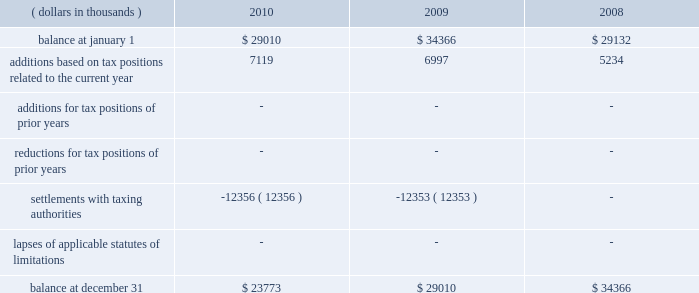A reconciliation of the beginning and ending amount of unrecognized tax benefits , for the periods indicated , is as follows: .
The entire amount of the unrecognized tax benefits would affect the effective tax rate if recognized .
In 2010 , the company favorably settled a 2003 and 2004 irs audit .
The company recorded a net overall tax benefit including accrued interest of $ 25920 thousand .
In addition , the company was also able to take down a $ 12356 thousand fin 48 reserve that had been established regarding the 2003 and 2004 irs audit .
The company is no longer subject to u.s .
Federal , state and local or foreign income tax examinations by tax authorities for years before 2007 .
The company recognizes accrued interest related to net unrecognized tax benefits and penalties in income taxes .
During the years ended december 31 , 2010 , 2009 and 2008 , the company accrued and recognized a net expense ( benefit ) of approximately $ ( 9938 ) thousand , $ 1563 thousand and $ 2446 thousand , respectively , in interest and penalties .
Included within the 2010 net expense ( benefit ) of $ ( 9938 ) thousand is $ ( 10591 ) thousand of accrued interest related to the 2003 and 2004 irs audit .
The company is not aware of any positions for which it is reasonably possible that the total amounts of unrecognized tax benefits will significantly increase or decrease within twelve months of the reporting date .
For u.s .
Income tax purposes the company has foreign tax credit carryforwards of $ 55026 thousand that begin to expire in 2014 .
In addition , for u.s .
Income tax purposes the company has $ 41693 thousand of alternative minimum tax credits that do not expire .
Management believes that it is more likely than not that the company will realize the benefits of its net deferred tax assets and , accordingly , no valuation allowance has been recorded for the periods presented .
Tax benefits of $ 629 thousand and $ 1714 thousand related to share-based compensation deductions for stock options exercised in 2010 and 2009 , respectively , are included within additional paid-in capital of the shareholders 2019 equity section of the consolidated balance sheets. .
What was the percent change in net expense in interest and penalties between 2008 and 2009? 
Computations: ((1563 - 2446) / 2446)
Answer: -0.361. A reconciliation of the beginning and ending amount of unrecognized tax benefits , for the periods indicated , is as follows: .
The entire amount of the unrecognized tax benefits would affect the effective tax rate if recognized .
In 2010 , the company favorably settled a 2003 and 2004 irs audit .
The company recorded a net overall tax benefit including accrued interest of $ 25920 thousand .
In addition , the company was also able to take down a $ 12356 thousand fin 48 reserve that had been established regarding the 2003 and 2004 irs audit .
The company is no longer subject to u.s .
Federal , state and local or foreign income tax examinations by tax authorities for years before 2007 .
The company recognizes accrued interest related to net unrecognized tax benefits and penalties in income taxes .
During the years ended december 31 , 2010 , 2009 and 2008 , the company accrued and recognized a net expense ( benefit ) of approximately $ ( 9938 ) thousand , $ 1563 thousand and $ 2446 thousand , respectively , in interest and penalties .
Included within the 2010 net expense ( benefit ) of $ ( 9938 ) thousand is $ ( 10591 ) thousand of accrued interest related to the 2003 and 2004 irs audit .
The company is not aware of any positions for which it is reasonably possible that the total amounts of unrecognized tax benefits will significantly increase or decrease within twelve months of the reporting date .
For u.s .
Income tax purposes the company has foreign tax credit carryforwards of $ 55026 thousand that begin to expire in 2014 .
In addition , for u.s .
Income tax purposes the company has $ 41693 thousand of alternative minimum tax credits that do not expire .
Management believes that it is more likely than not that the company will realize the benefits of its net deferred tax assets and , accordingly , no valuation allowance has been recorded for the periods presented .
Tax benefits of $ 629 thousand and $ 1714 thousand related to share-based compensation deductions for stock options exercised in 2010 and 2009 , respectively , are included within additional paid-in capital of the shareholders 2019 equity section of the consolidated balance sheets. .
Between 2008 and 2010 what was the ratio of the company accrued and recognized a net benefit to expenses? 
Computations: (9938 / (1563 + 2446))
Answer: 2.47892. A reconciliation of the beginning and ending amount of unrecognized tax benefits , for the periods indicated , is as follows: .
The entire amount of the unrecognized tax benefits would affect the effective tax rate if recognized .
In 2010 , the company favorably settled a 2003 and 2004 irs audit .
The company recorded a net overall tax benefit including accrued interest of $ 25920 thousand .
In addition , the company was also able to take down a $ 12356 thousand fin 48 reserve that had been established regarding the 2003 and 2004 irs audit .
The company is no longer subject to u.s .
Federal , state and local or foreign income tax examinations by tax authorities for years before 2007 .
The company recognizes accrued interest related to net unrecognized tax benefits and penalties in income taxes .
During the years ended december 31 , 2010 , 2009 and 2008 , the company accrued and recognized a net expense ( benefit ) of approximately $ ( 9938 ) thousand , $ 1563 thousand and $ 2446 thousand , respectively , in interest and penalties .
Included within the 2010 net expense ( benefit ) of $ ( 9938 ) thousand is $ ( 10591 ) thousand of accrued interest related to the 2003 and 2004 irs audit .
The company is not aware of any positions for which it is reasonably possible that the total amounts of unrecognized tax benefits will significantly increase or decrease within twelve months of the reporting date .
For u.s .
Income tax purposes the company has foreign tax credit carryforwards of $ 55026 thousand that begin to expire in 2014 .
In addition , for u.s .
Income tax purposes the company has $ 41693 thousand of alternative minimum tax credits that do not expire .
Management believes that it is more likely than not that the company will realize the benefits of its net deferred tax assets and , accordingly , no valuation allowance has been recorded for the periods presented .
Tax benefits of $ 629 thousand and $ 1714 thousand related to share-based compensation deductions for stock options exercised in 2010 and 2009 , respectively , are included within additional paid-in capital of the shareholders 2019 equity section of the consolidated balance sheets. .
What is the percent change of the beginning and ending amount of unrecognized tax benefits in 2009? 
Computations: ((29010 - 34366) / 34366)
Answer: -0.15585. 